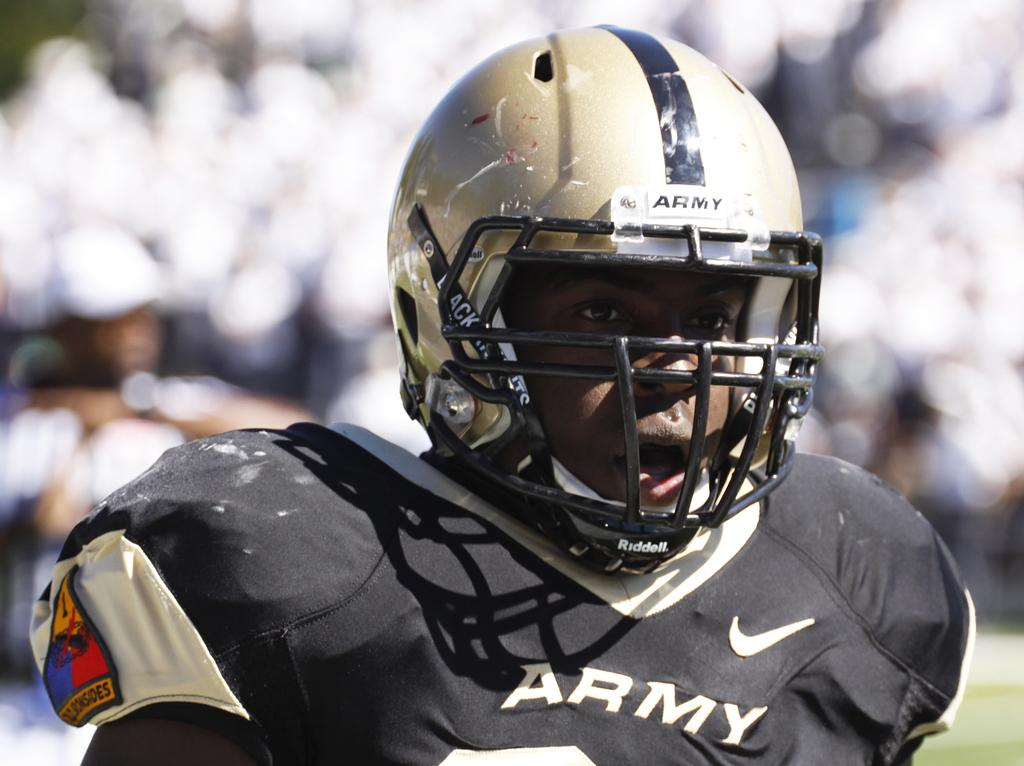What can be seen in the image? There is a person in the image. What is the person wearing on their head? The person is wearing a helmet. How clear is the image? The image is blurry at the back. What is written or printed on the person's dress? There is text on the person's dress. Can you see any grass growing on the person's tongue in the image? There is no grass or tongue visible in the image, as it features a person wearing a helmet and text on their dress. 